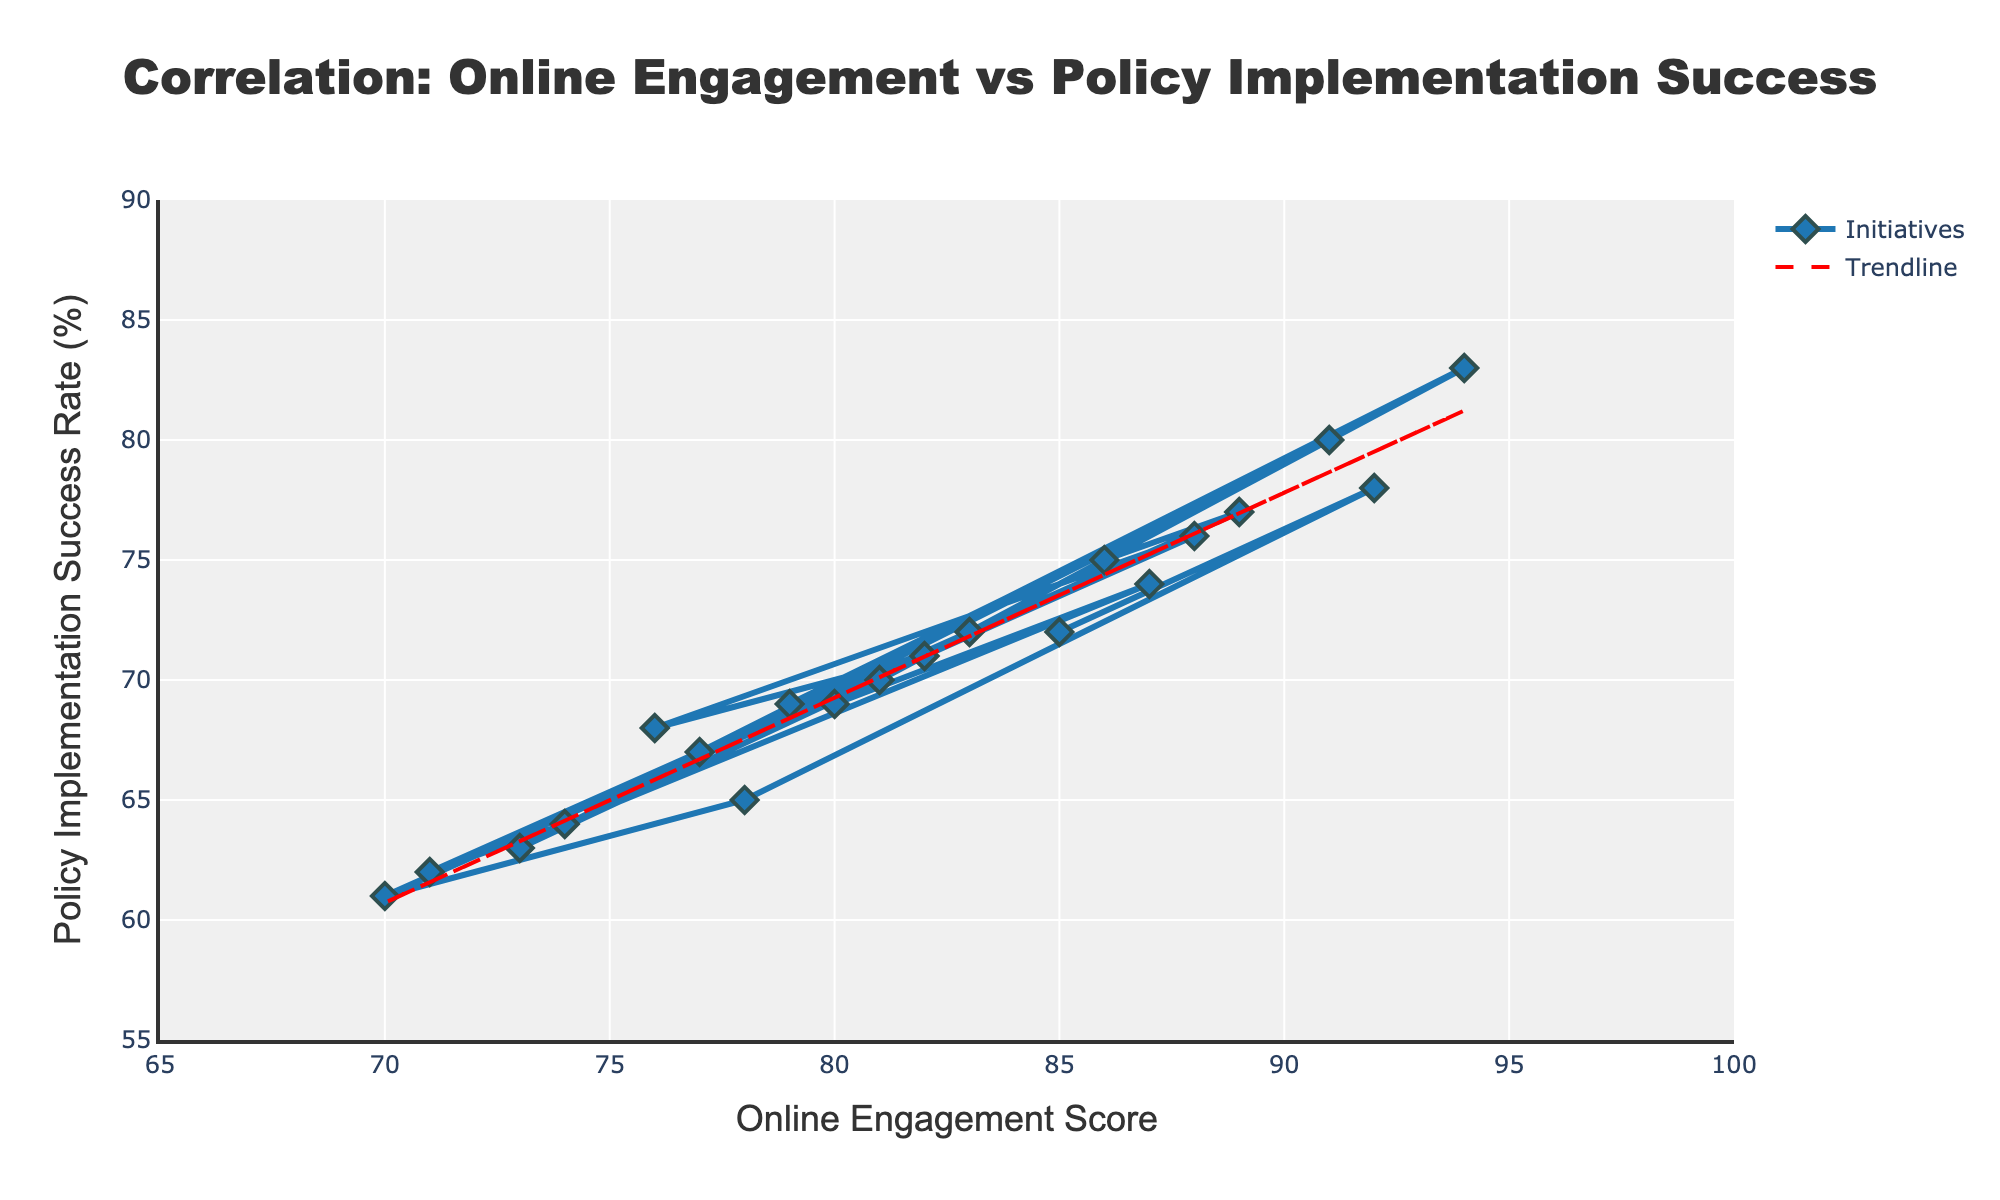Which initiative has the highest online engagement score? By observing the scatter plot, find the point that is furthest to the right on the x-axis, as this denotes the highest online engagement score. The "Citizen Feedback System" is positioned at the highest point on the x-axis with a score of 94.
Answer: Citizen Feedback System Which initiative has the lowest policy implementation success rate? Identify the point that is lowest on the y-axis, which indicates the lowest policy implementation success rate. The "Recycling Awareness Campaign" has the lowest success rate at 61.
Answer: Recycling Awareness Campaign What is the difference in policy implementation success rates between the "Open Data Platform" and the "Affordable Housing Scheme"? Locate both initiatives on the scatter plot and note their success rates. The "Open Data Platform" has a success rate of 80%, and the "Affordable Housing Scheme" has a success rate of 63%. The difference is 80 - 63 = 17%.
Answer: 17% How many initiatives have a policy implementation success rate above 70%? Count the number of data points (initiatives) that are positioned above the 70% line on the y-axis. Data points with success rates above 70% include initiatives with success rates 72, 78, 76, 75, 77, 83, 74, 72 which total 9 initiatives.
Answer: 9 What is the average online engagement score for initiatives with a policy implementation success rate below 65%? Identify the initiatives with success rates below 65% ("Digital Literacy Program", "Recycling Awareness Campaign", and "Affordable Housing Scheme", "Cultural Heritage Preservation" and "Senior Digital Inclusion Program"). Their engagement scores are 78, 70, 73, 74, and 71 respectively. Calculate the average: (78 + 70 + 73 + 74 + 71) / 5 = 73.2.
Answer: 73.2 Which initiative has both a high engagement and high success rate, close to or above the trendline? Look for points near the trendline in the higher range of both x (engagement score) and y (success rate). The "Citizen Feedback System" is both above the trendline and highest in both metrics with 94 for engagement and 83 for success rate.
Answer: Citizen Feedback System What is the correlation between online engagement scores and policy implementation success rates as depicted by the scatter plot and trendline? The trendline indicates a positive correlation, meaning as the online engagement score increases, the policy implementation success rate also tends to increase. The rising red dashed trendline demonstrates this positive relationship.
Answer: Positive correlation Which two initiatives have the closest policy implementation success rates, and what is their difference? Identify initiatives with overlapping or very close y-values. "Youth Employment Program" and "Neighborhood Safety Initiative" both have success rates of 69%. The difference is 69 - 69 = 0%.
Answer: Youth Employment Program and Neighborhood Safety Initiative, 0% What is the visual representation of the overall trend in the plot? Look for the direction of the trendline (red dashed line). The trendline slopes upward from left to right, indicating that as online engagement scores increase, so do policy implementation success rates.
Answer: Upward trend 